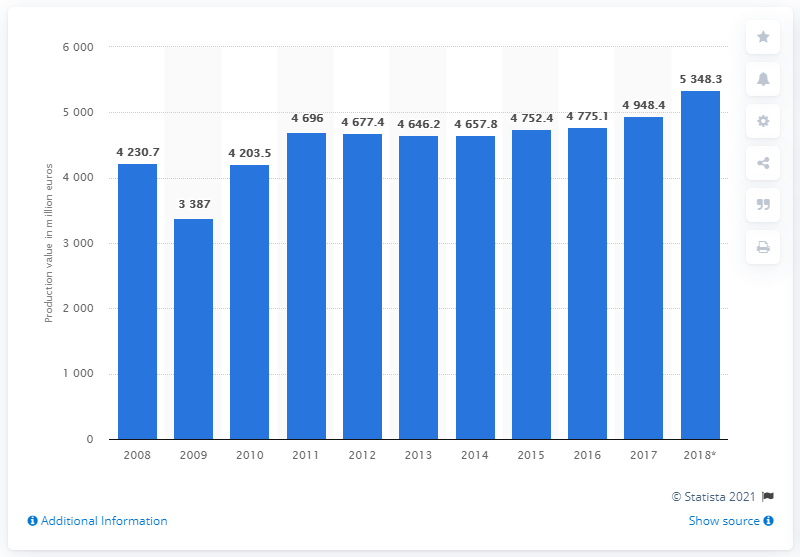Outline some significant characteristics in this image. In 2017, the annual production value of Sweden's manufacturing sector for rubber and plastic products was 49,484.4. 